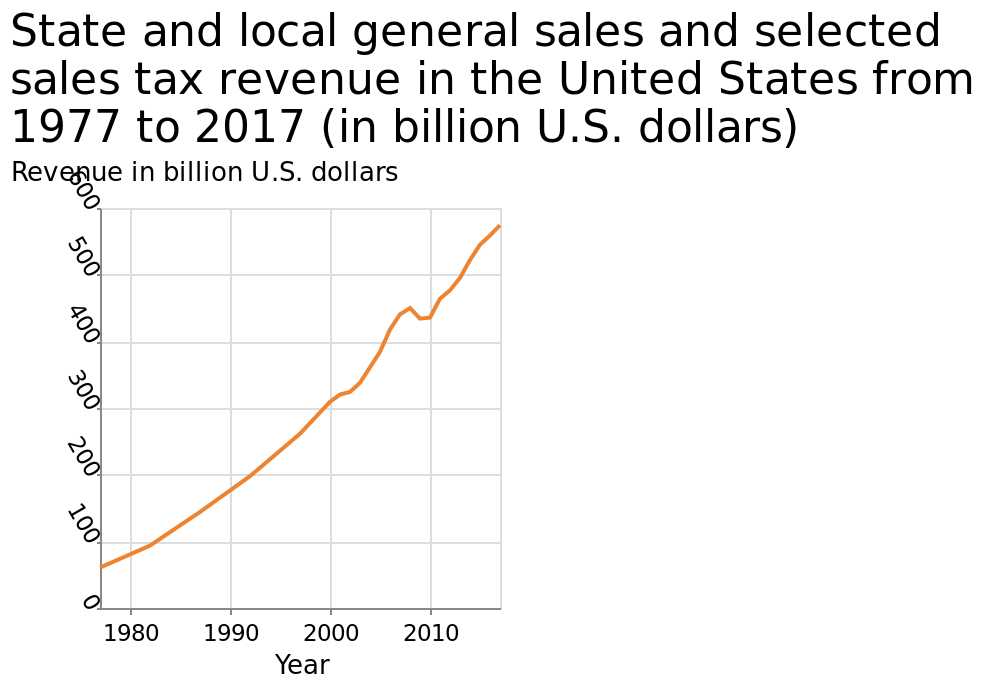<image>
Offer a thorough analysis of the image. There was a dip in the overall growth around 2010 to 450 billion dollars. Overall the chart shows a progressive rise. 